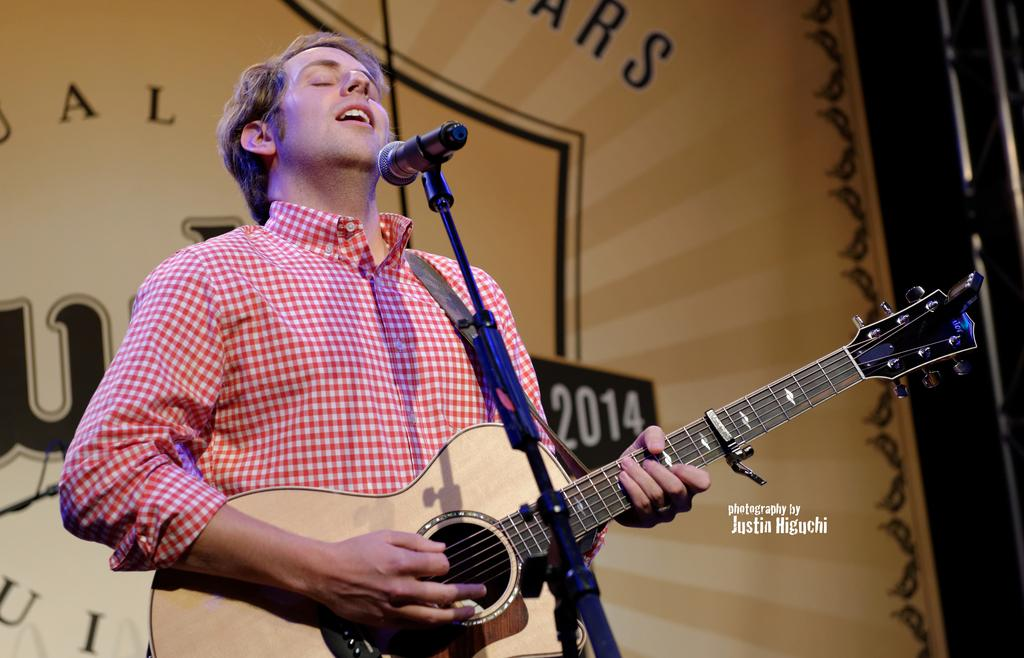What is the main subject of the image? There is a man in the image. What is the man doing in the image? The man is standing in the image. What object is the man holding in the image? The man is holding a guitar in his hand. What type of roof can be seen on the guitar in the image? There is no roof present on the guitar in the image, as guitars do not have roofs. 